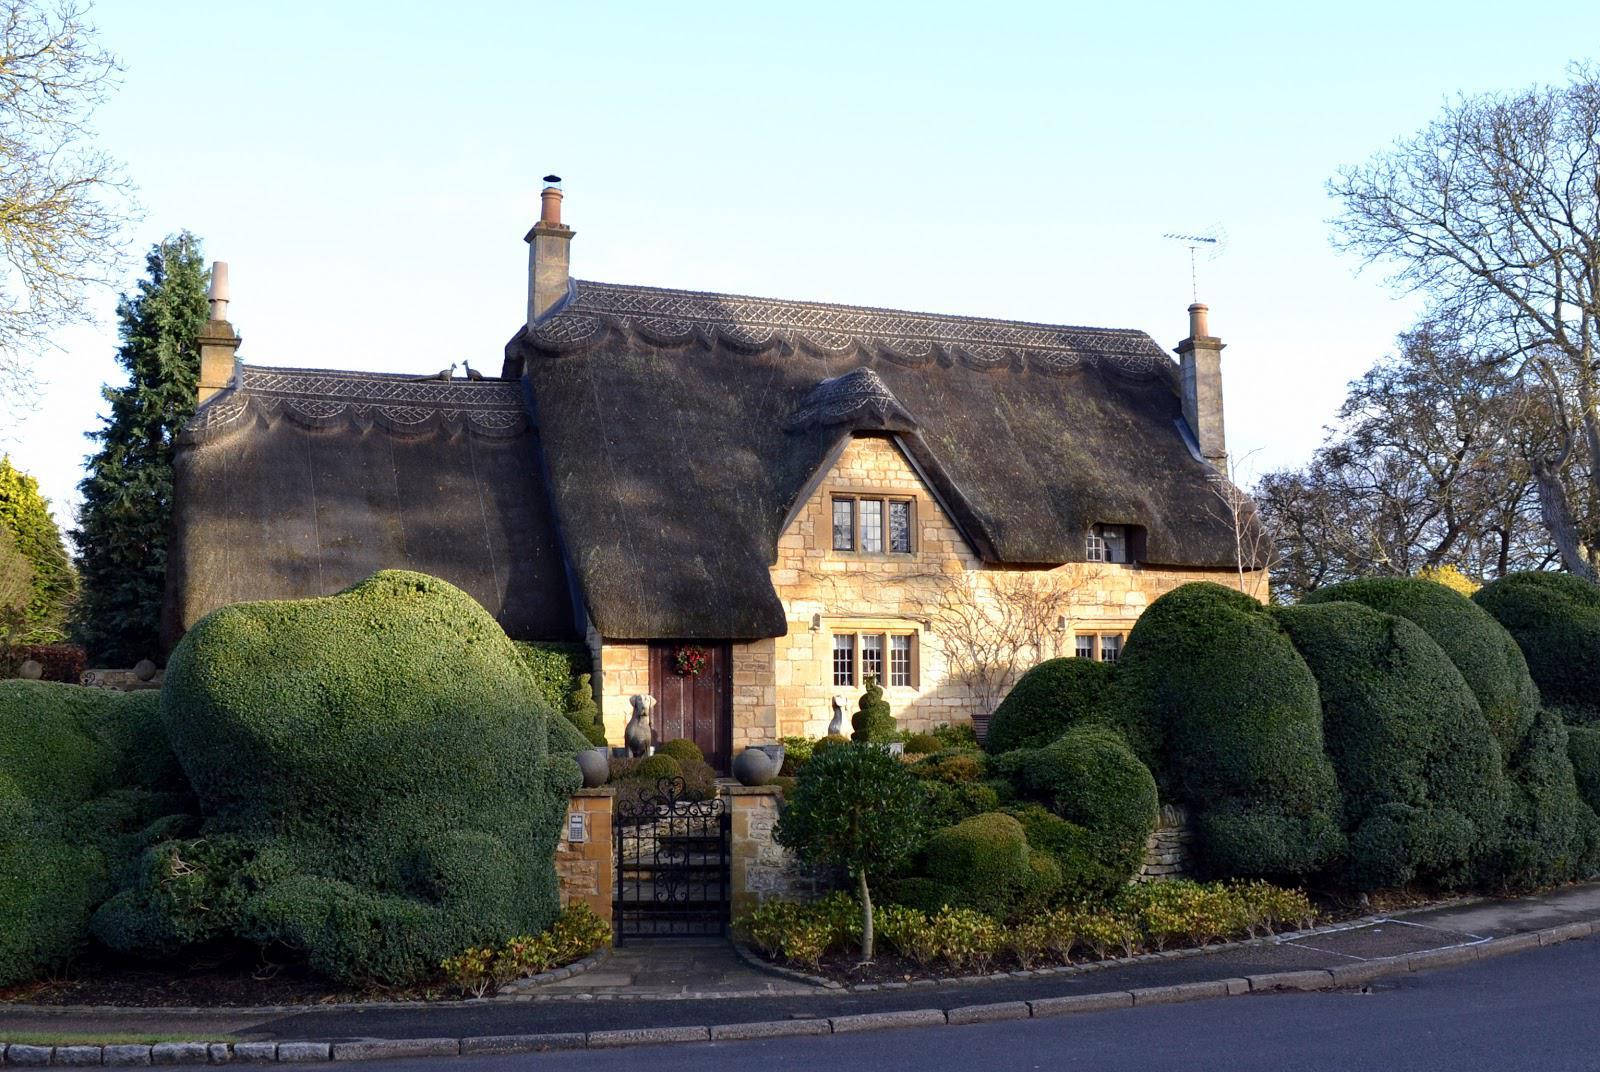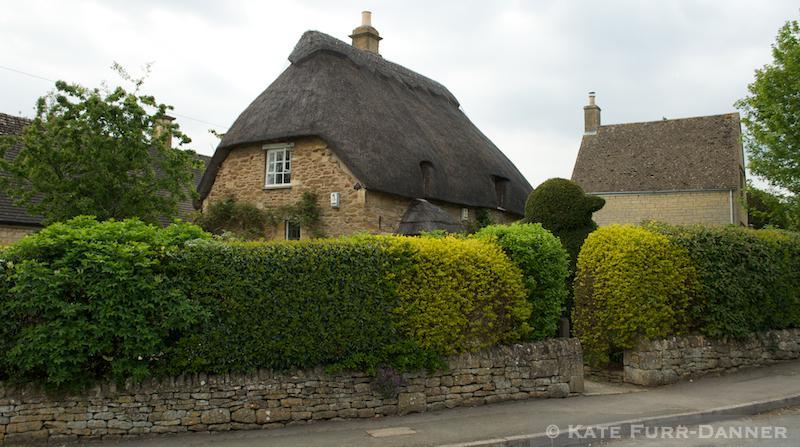The first image is the image on the left, the second image is the image on the right. Evaluate the accuracy of this statement regarding the images: "In at least one image there are at least four oversized green bushes blocking the front of a home with at least two chimneys". Is it true? Answer yes or no. Yes. The first image is the image on the left, the second image is the image on the right. Analyze the images presented: Is the assertion "The left image features a house with multiple chimneys atop a dark gray roof with a scalloped border on top, and curving asymmetrical hedges in front." valid? Answer yes or no. Yes. 